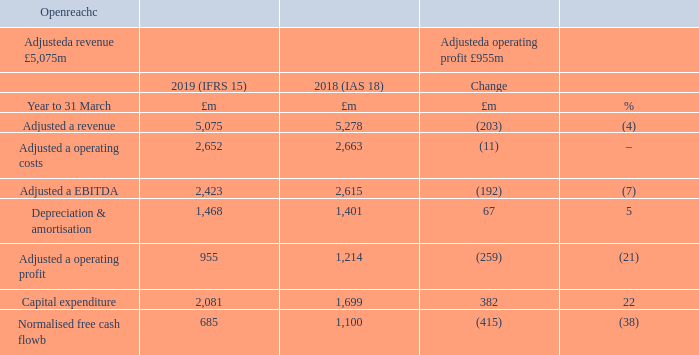Openreach has a UK-wide presence which is overlapped by our competitors in around half the country. This overlap is expected to grow as alternative network providers build-out new fibre footprint. Our volume discount deal, signed with the majority of our major communications provider customers, has led to another record quarter for fibre sales. We are also rapidly expanding our fibre-to-the-premises network to provide the next generation of services for our customers. We have experienced strong demand from businesses for Ethernet circuits for the second consecutive quarter.
Adjusteda revenue decline of 4% for the year was driven by regulated price reductions predominantly on FTTC and Ethernet products, non-regulated price reductions (mainly driven by communications providers signing up for fibre volume discounts), a small decline in our physical line base and a reclassification of costs to revenue. This was partly offset by 25% growth in our fibre rental base, a 9% increase in our Ethernet rental base and the impact of adopting IFRS 15.
Adjusteda operating costs were broadly flat, with higher costs from recruiting and training engineers to support our ‘Fibre First’ programme and help improve customer experience, as well as pay inflation and business rates, offset by efficiency savings and a reclassification of costs to revenue. Adjusteda EBITDA was down 7% for the year.
Capital expenditure was £2.1bn, up 22%, driven by investment in our FTTP and Gfast network build and higher year-on-year BDUK net grant funding deferrals, partly offset by efficiency savings.
Normalised free cash flowb was down 38% due to the EBITDA decline, higher underlying capital expenditure (excluding BDUK grant funding deferrals) and timing of customer receipts.
a Adjusted measures exclude specific items, as explained in the Additional Information on page 185. b Free cash flow after net interest paid, before pension deficit payments (including the cash tax benefit of pension deficit payments) and specific items. c Openreach comparatives have been re-presented to reflect the transfer of Northern Ireland Networks from Enterprise to Openreach.
What is the  Adjusted a revenue for 2019?
Answer scale should be: million. 5,075. What was the reason for decrease in Adjusteda revenue decline? Driven by regulated price reductions predominantly on fttc and ethernet products, non-regulated price reductions (mainly driven by communications providers signing up for fibre volume discounts), a small decline in our physical line base and a reclassification of costs to revenue. What was  Capital expenditure for 2018 and 2019 respectively?
Answer scale should be: million. 1,699, 2,081. What was the average Adjusted EBITDA for 2018 and 2019?
Answer scale should be: million. (2,423 + 2,615) / 2
Answer: 2519. What  was the EBITDA margin in 2019? 2,423 / 5,075
Answer: 0.48. What is the average Adjusteda operating costs for 2018 and 2019?
Answer scale should be: million. (2,652 + 2,663) / 2
Answer: 2657.5. 